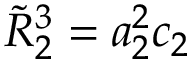Convert formula to latex. <formula><loc_0><loc_0><loc_500><loc_500>\tilde { R } _ { 2 } ^ { 3 } = a _ { 2 } ^ { 2 } c _ { 2 }</formula> 